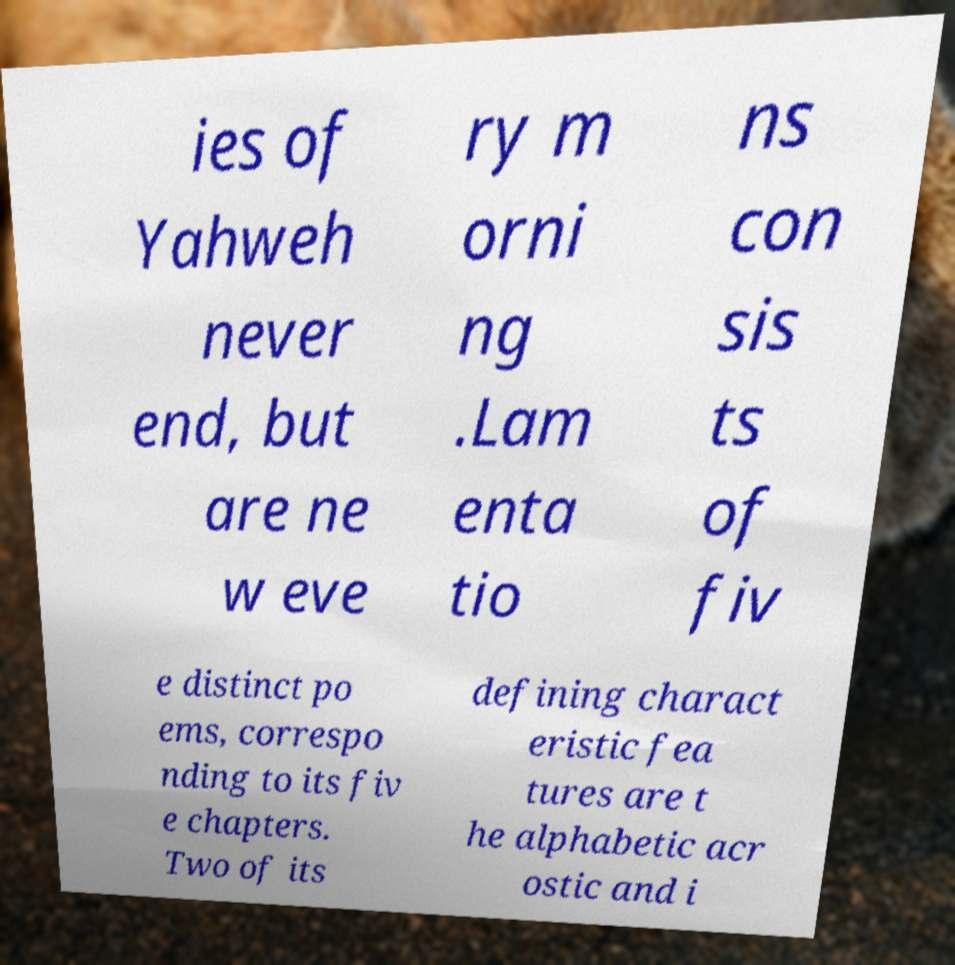Please identify and transcribe the text found in this image. ies of Yahweh never end, but are ne w eve ry m orni ng .Lam enta tio ns con sis ts of fiv e distinct po ems, correspo nding to its fiv e chapters. Two of its defining charact eristic fea tures are t he alphabetic acr ostic and i 